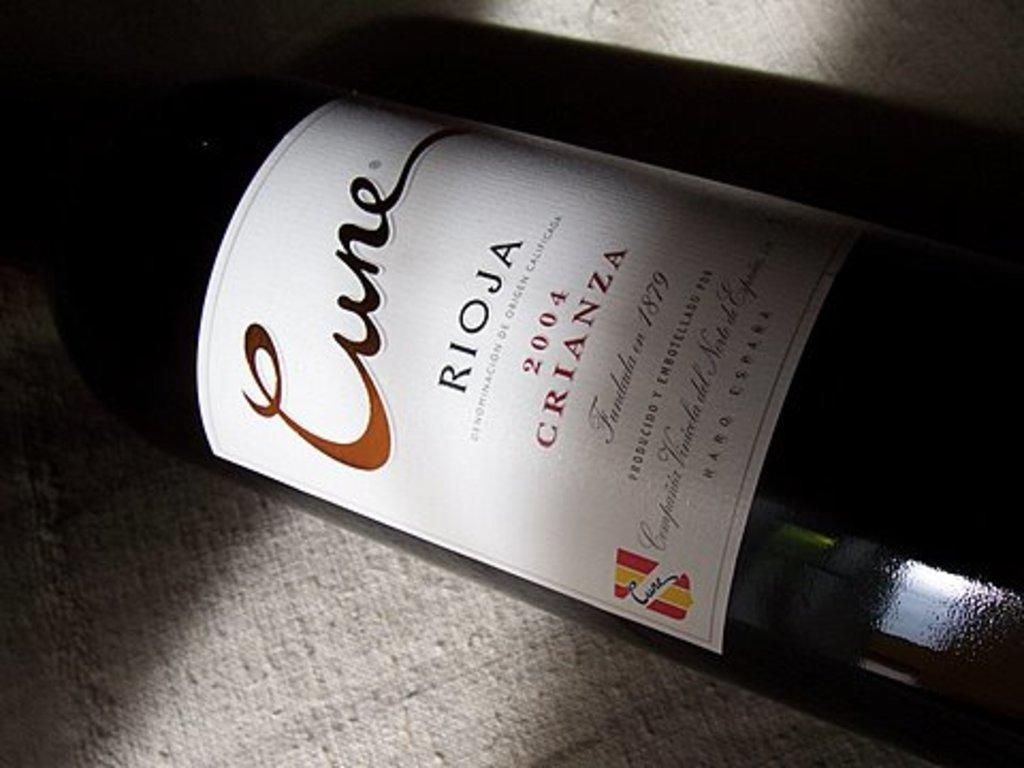<image>
Render a clear and concise summary of the photo. The year on this bottle of wine is 2004 